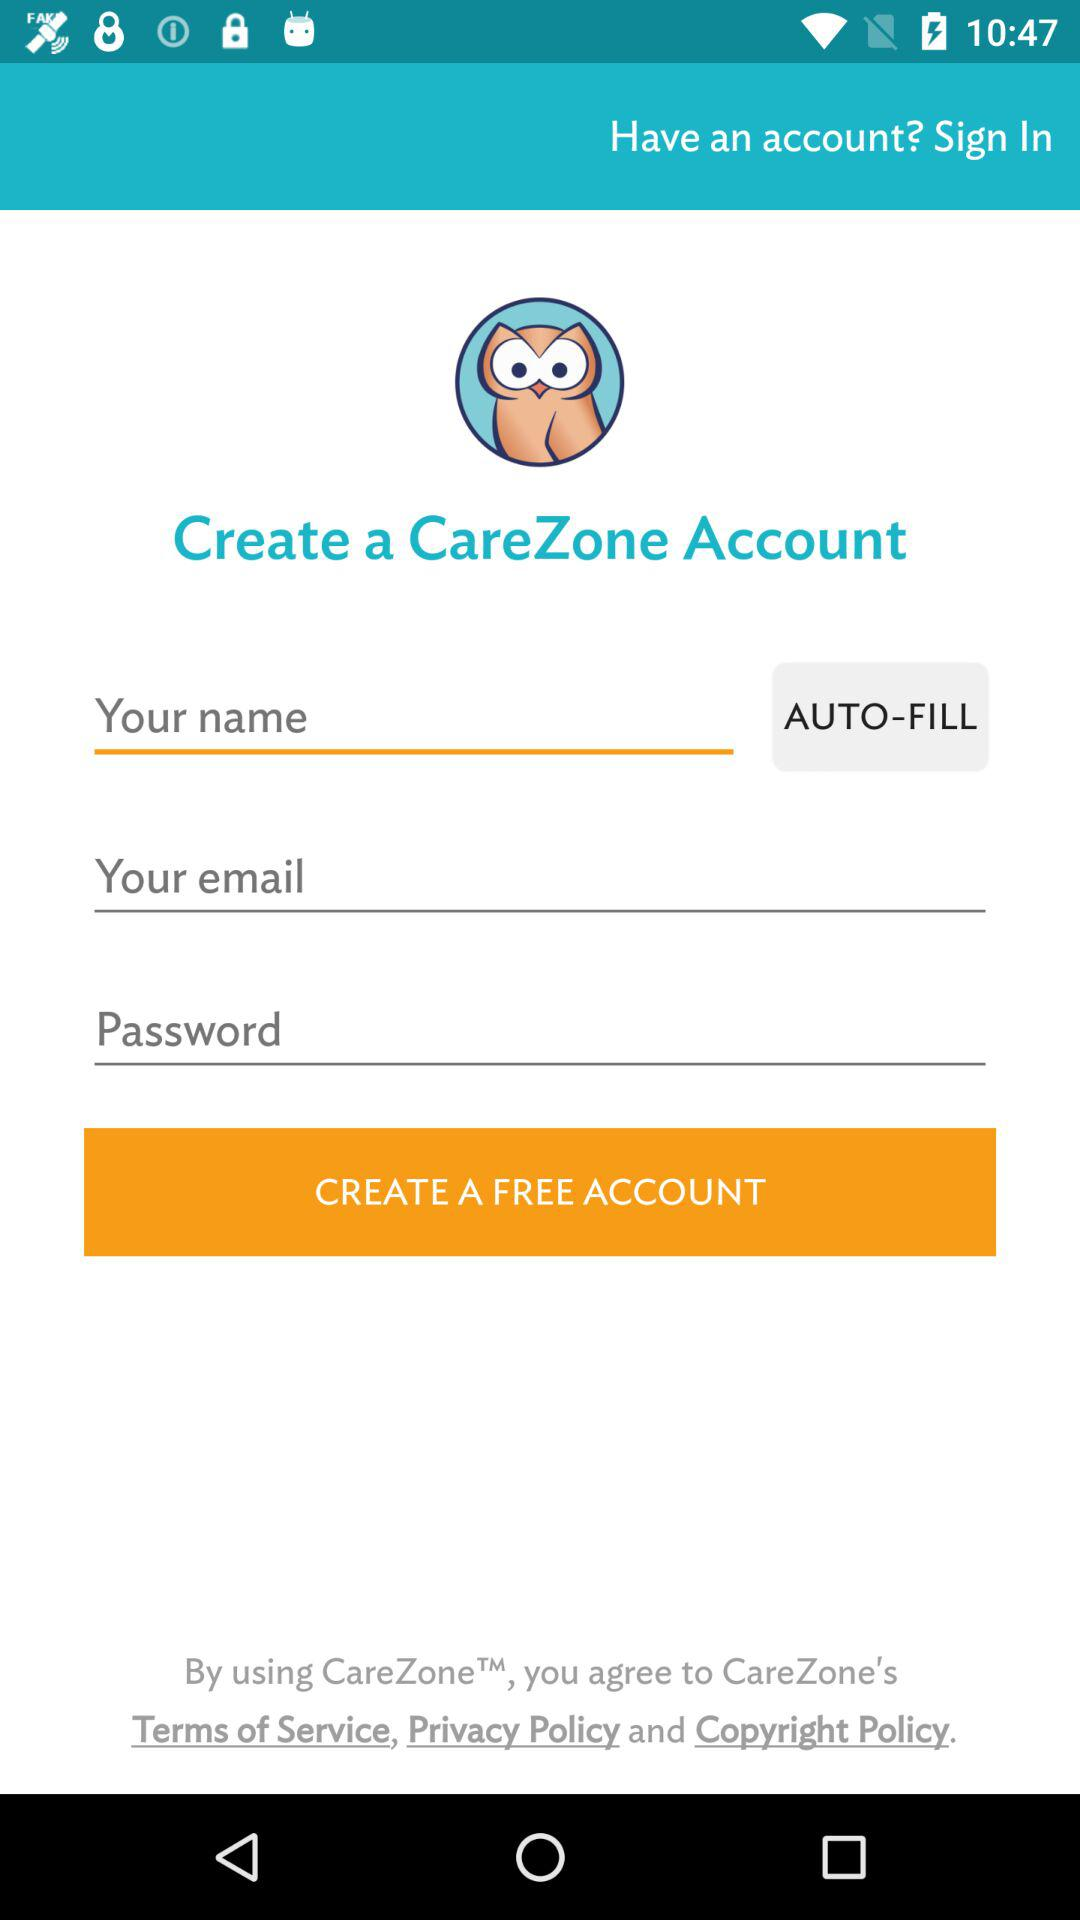What is the app name? The app name is "CareZone". 